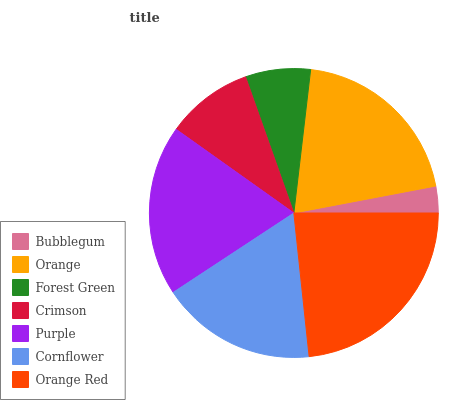Is Bubblegum the minimum?
Answer yes or no. Yes. Is Orange Red the maximum?
Answer yes or no. Yes. Is Orange the minimum?
Answer yes or no. No. Is Orange the maximum?
Answer yes or no. No. Is Orange greater than Bubblegum?
Answer yes or no. Yes. Is Bubblegum less than Orange?
Answer yes or no. Yes. Is Bubblegum greater than Orange?
Answer yes or no. No. Is Orange less than Bubblegum?
Answer yes or no. No. Is Cornflower the high median?
Answer yes or no. Yes. Is Cornflower the low median?
Answer yes or no. Yes. Is Forest Green the high median?
Answer yes or no. No. Is Bubblegum the low median?
Answer yes or no. No. 